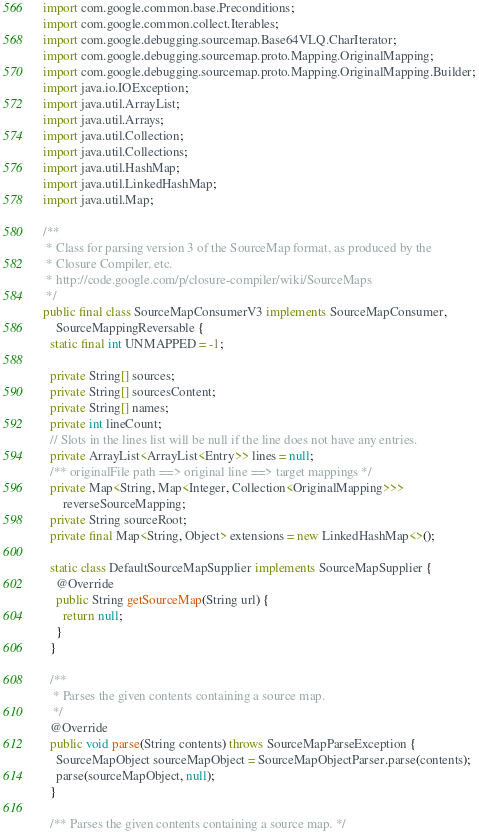Convert code to text. <code><loc_0><loc_0><loc_500><loc_500><_Java_>import com.google.common.base.Preconditions;
import com.google.common.collect.Iterables;
import com.google.debugging.sourcemap.Base64VLQ.CharIterator;
import com.google.debugging.sourcemap.proto.Mapping.OriginalMapping;
import com.google.debugging.sourcemap.proto.Mapping.OriginalMapping.Builder;
import java.io.IOException;
import java.util.ArrayList;
import java.util.Arrays;
import java.util.Collection;
import java.util.Collections;
import java.util.HashMap;
import java.util.LinkedHashMap;
import java.util.Map;

/**
 * Class for parsing version 3 of the SourceMap format, as produced by the
 * Closure Compiler, etc.
 * http://code.google.com/p/closure-compiler/wiki/SourceMaps
 */
public final class SourceMapConsumerV3 implements SourceMapConsumer,
    SourceMappingReversable {
  static final int UNMAPPED = -1;

  private String[] sources;
  private String[] sourcesContent;
  private String[] names;
  private int lineCount;
  // Slots in the lines list will be null if the line does not have any entries.
  private ArrayList<ArrayList<Entry>> lines = null;
  /** originalFile path ==> original line ==> target mappings */
  private Map<String, Map<Integer, Collection<OriginalMapping>>>
      reverseSourceMapping;
  private String sourceRoot;
  private final Map<String, Object> extensions = new LinkedHashMap<>();

  static class DefaultSourceMapSupplier implements SourceMapSupplier {
    @Override
    public String getSourceMap(String url) {
      return null;
    }
  }

  /**
   * Parses the given contents containing a source map.
   */
  @Override
  public void parse(String contents) throws SourceMapParseException {
    SourceMapObject sourceMapObject = SourceMapObjectParser.parse(contents);
    parse(sourceMapObject, null);
  }

  /** Parses the given contents containing a source map. */</code> 